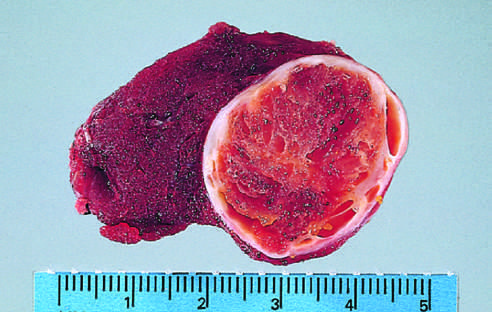what is composed of cells with abundant eosinophilic cytoplasm and small regular nuclei on this high-power view?
Answer the question using a single word or phrase. The tumor 